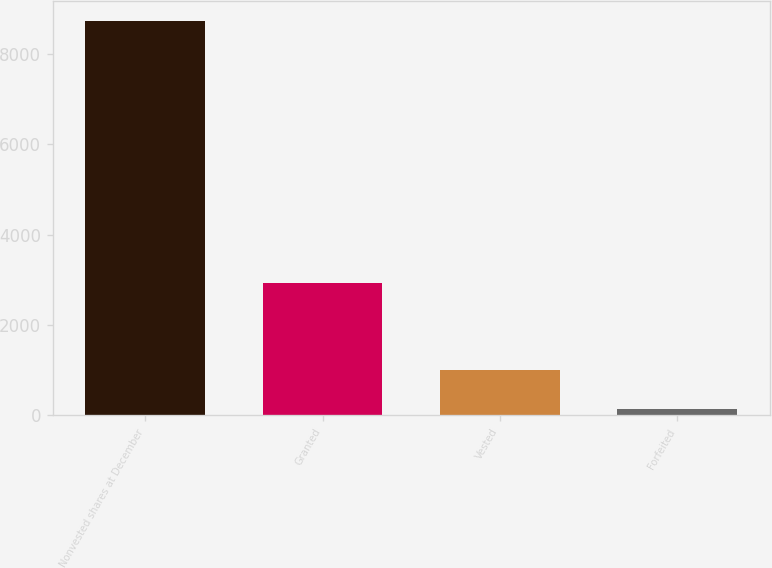Convert chart. <chart><loc_0><loc_0><loc_500><loc_500><bar_chart><fcel>Nonvested shares at December<fcel>Granted<fcel>Vested<fcel>Forfeited<nl><fcel>8729<fcel>2922<fcel>1004.3<fcel>146<nl></chart> 